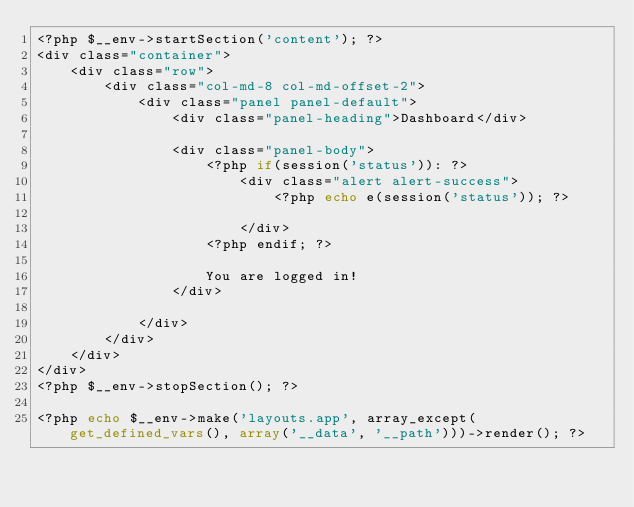Convert code to text. <code><loc_0><loc_0><loc_500><loc_500><_PHP_><?php $__env->startSection('content'); ?>
<div class="container">
    <div class="row">
        <div class="col-md-8 col-md-offset-2">
            <div class="panel panel-default">
                <div class="panel-heading">Dashboard</div>

                <div class="panel-body">
                    <?php if(session('status')): ?>
                        <div class="alert alert-success">
                            <?php echo e(session('status')); ?>

                        </div>
                    <?php endif; ?>

                    You are logged in!
                </div>
               
            </div>
        </div>
    </div>
</div>
<?php $__env->stopSection(); ?>

<?php echo $__env->make('layouts.app', array_except(get_defined_vars(), array('__data', '__path')))->render(); ?></code> 